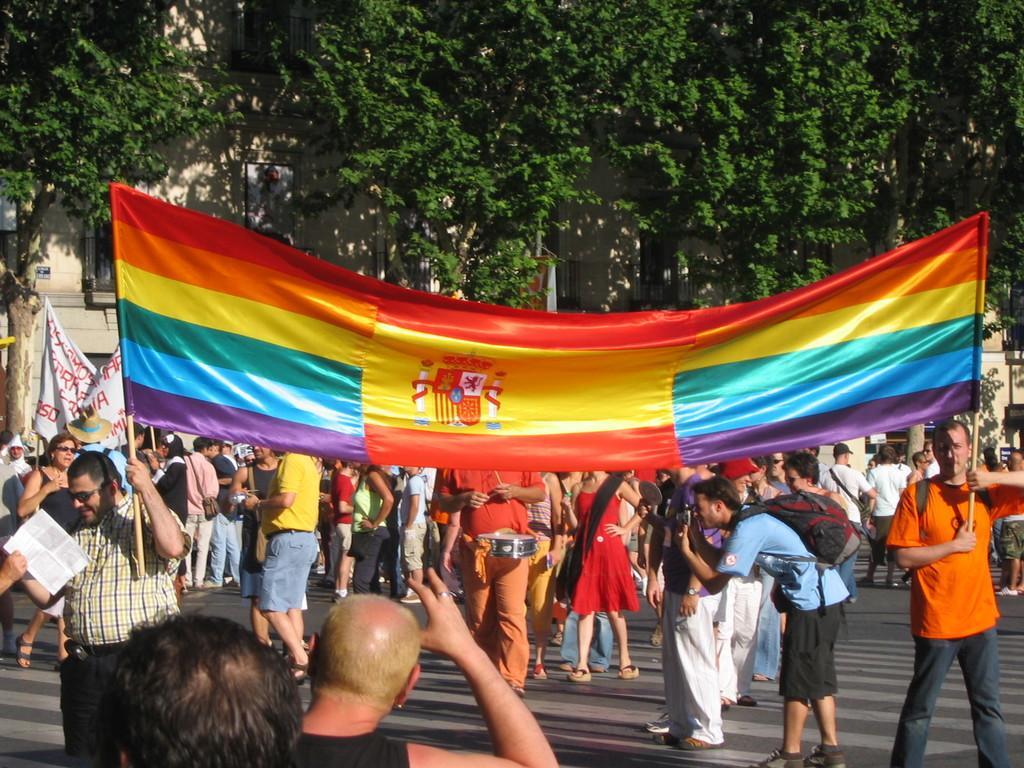How would you summarize this image in a sentence or two? In this image we can see a group of people protesting, a few of them are holding posters, some of them are taking photos and a few are carrying other objects, in the background there are trees and buildings. 